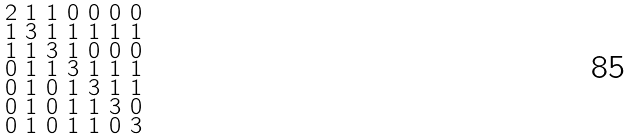Convert formula to latex. <formula><loc_0><loc_0><loc_500><loc_500>\begin{smallmatrix} 2 & 1 & 1 & 0 & 0 & 0 & 0 \\ 1 & 3 & 1 & 1 & 1 & 1 & 1 \\ 1 & 1 & 3 & 1 & 0 & 0 & 0 \\ 0 & 1 & 1 & 3 & 1 & 1 & 1 \\ 0 & 1 & 0 & 1 & 3 & 1 & 1 \\ 0 & 1 & 0 & 1 & 1 & 3 & 0 \\ 0 & 1 & 0 & 1 & 1 & 0 & 3 \end{smallmatrix}</formula> 